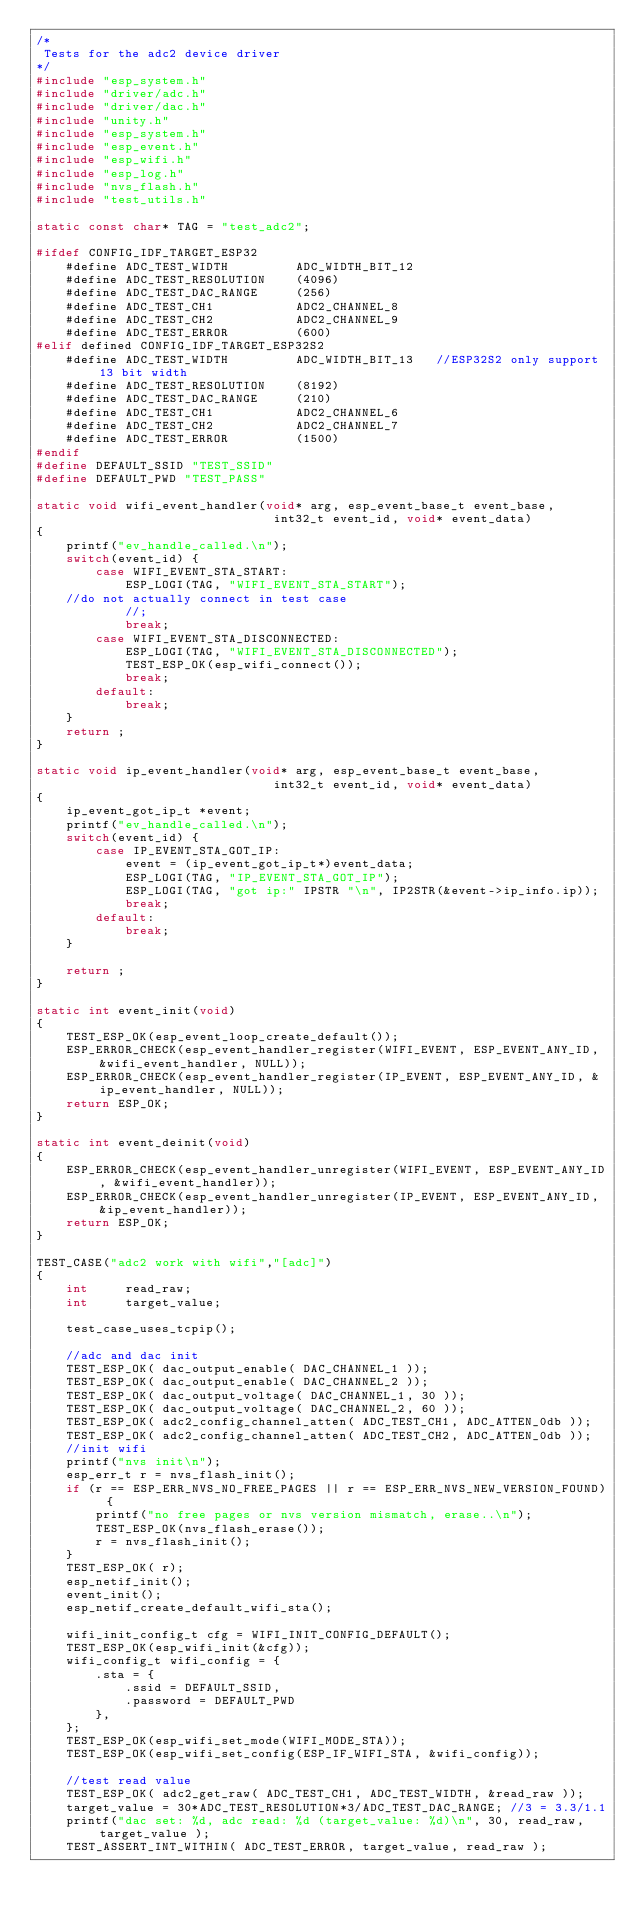<code> <loc_0><loc_0><loc_500><loc_500><_C_>/*
 Tests for the adc2 device driver
*/
#include "esp_system.h"
#include "driver/adc.h"
#include "driver/dac.h"
#include "unity.h"
#include "esp_system.h"
#include "esp_event.h"
#include "esp_wifi.h"
#include "esp_log.h"
#include "nvs_flash.h"
#include "test_utils.h"

static const char* TAG = "test_adc2";

#ifdef CONFIG_IDF_TARGET_ESP32
    #define ADC_TEST_WIDTH         ADC_WIDTH_BIT_12
    #define ADC_TEST_RESOLUTION    (4096)
    #define ADC_TEST_DAC_RANGE     (256)
    #define ADC_TEST_CH1           ADC2_CHANNEL_8
    #define ADC_TEST_CH2           ADC2_CHANNEL_9
    #define ADC_TEST_ERROR         (600)
#elif defined CONFIG_IDF_TARGET_ESP32S2
    #define ADC_TEST_WIDTH         ADC_WIDTH_BIT_13   //ESP32S2 only support 13 bit width
    #define ADC_TEST_RESOLUTION    (8192)
    #define ADC_TEST_DAC_RANGE     (210)
    #define ADC_TEST_CH1           ADC2_CHANNEL_6
    #define ADC_TEST_CH2           ADC2_CHANNEL_7
    #define ADC_TEST_ERROR         (1500)
#endif
#define DEFAULT_SSID "TEST_SSID"
#define DEFAULT_PWD "TEST_PASS"

static void wifi_event_handler(void* arg, esp_event_base_t event_base,
                                int32_t event_id, void* event_data)
{
    printf("ev_handle_called.\n");
    switch(event_id) {
        case WIFI_EVENT_STA_START:
            ESP_LOGI(TAG, "WIFI_EVENT_STA_START");
    //do not actually connect in test case
            //;
            break;
        case WIFI_EVENT_STA_DISCONNECTED:
            ESP_LOGI(TAG, "WIFI_EVENT_STA_DISCONNECTED");
            TEST_ESP_OK(esp_wifi_connect());
            break;
        default:
            break;
    }
    return ;
}

static void ip_event_handler(void* arg, esp_event_base_t event_base,
                                int32_t event_id, void* event_data)
{
    ip_event_got_ip_t *event;
    printf("ev_handle_called.\n");
    switch(event_id) {
        case IP_EVENT_STA_GOT_IP:
            event = (ip_event_got_ip_t*)event_data;
            ESP_LOGI(TAG, "IP_EVENT_STA_GOT_IP");
            ESP_LOGI(TAG, "got ip:" IPSTR "\n", IP2STR(&event->ip_info.ip));
            break;
        default:
            break;
    }

    return ;
}

static int event_init(void)
{
    TEST_ESP_OK(esp_event_loop_create_default());
    ESP_ERROR_CHECK(esp_event_handler_register(WIFI_EVENT, ESP_EVENT_ANY_ID, &wifi_event_handler, NULL));
    ESP_ERROR_CHECK(esp_event_handler_register(IP_EVENT, ESP_EVENT_ANY_ID, &ip_event_handler, NULL));
    return ESP_OK;
}

static int event_deinit(void)
{
    ESP_ERROR_CHECK(esp_event_handler_unregister(WIFI_EVENT, ESP_EVENT_ANY_ID, &wifi_event_handler));
    ESP_ERROR_CHECK(esp_event_handler_unregister(IP_EVENT, ESP_EVENT_ANY_ID, &ip_event_handler));
    return ESP_OK;
}

TEST_CASE("adc2 work with wifi","[adc]")
{
    int     read_raw;
    int     target_value;

    test_case_uses_tcpip();

    //adc and dac init
    TEST_ESP_OK( dac_output_enable( DAC_CHANNEL_1 ));
    TEST_ESP_OK( dac_output_enable( DAC_CHANNEL_2 ));
    TEST_ESP_OK( dac_output_voltage( DAC_CHANNEL_1, 30 ));
    TEST_ESP_OK( dac_output_voltage( DAC_CHANNEL_2, 60 ));
    TEST_ESP_OK( adc2_config_channel_atten( ADC_TEST_CH1, ADC_ATTEN_0db ));
    TEST_ESP_OK( adc2_config_channel_atten( ADC_TEST_CH2, ADC_ATTEN_0db ));
    //init wifi
    printf("nvs init\n");
    esp_err_t r = nvs_flash_init();
    if (r == ESP_ERR_NVS_NO_FREE_PAGES || r == ESP_ERR_NVS_NEW_VERSION_FOUND) {
        printf("no free pages or nvs version mismatch, erase..\n");
        TEST_ESP_OK(nvs_flash_erase());
        r = nvs_flash_init();
    }
    TEST_ESP_OK( r);
    esp_netif_init();
    event_init();
    esp_netif_create_default_wifi_sta();

    wifi_init_config_t cfg = WIFI_INIT_CONFIG_DEFAULT();
    TEST_ESP_OK(esp_wifi_init(&cfg));
    wifi_config_t wifi_config = {
        .sta = {
            .ssid = DEFAULT_SSID,
            .password = DEFAULT_PWD
        },
    };
    TEST_ESP_OK(esp_wifi_set_mode(WIFI_MODE_STA));
    TEST_ESP_OK(esp_wifi_set_config(ESP_IF_WIFI_STA, &wifi_config));

    //test read value
    TEST_ESP_OK( adc2_get_raw( ADC_TEST_CH1, ADC_TEST_WIDTH, &read_raw ));
    target_value = 30*ADC_TEST_RESOLUTION*3/ADC_TEST_DAC_RANGE; //3 = 3.3/1.1
    printf("dac set: %d, adc read: %d (target_value: %d)\n", 30, read_raw, target_value );
    TEST_ASSERT_INT_WITHIN( ADC_TEST_ERROR, target_value, read_raw );</code> 